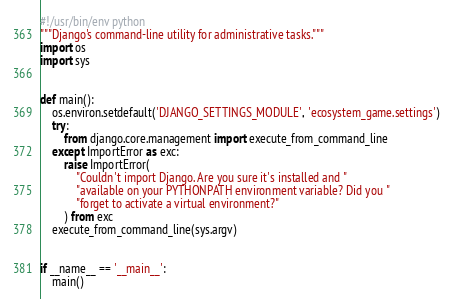<code> <loc_0><loc_0><loc_500><loc_500><_Python_>#!/usr/bin/env python
"""Django's command-line utility for administrative tasks."""
import os
import sys


def main():
    os.environ.setdefault('DJANGO_SETTINGS_MODULE', 'ecosystem_game.settings')
    try:
        from django.core.management import execute_from_command_line
    except ImportError as exc:
        raise ImportError(
            "Couldn't import Django. Are you sure it's installed and "
            "available on your PYTHONPATH environment variable? Did you "
            "forget to activate a virtual environment?"
        ) from exc
    execute_from_command_line(sys.argv)


if __name__ == '__main__':
    main()
</code> 